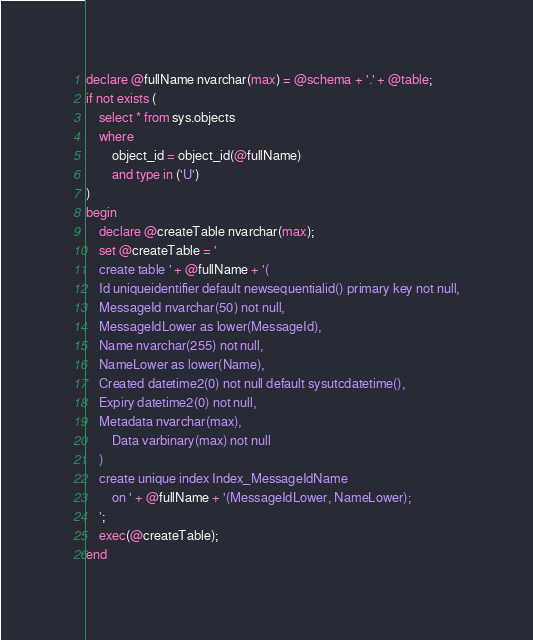<code> <loc_0><loc_0><loc_500><loc_500><_SQL_>declare @fullName nvarchar(max) = @schema + '.' + @table;
if not exists (
    select * from sys.objects
    where
        object_id = object_id(@fullName)
        and type in ('U')
)
begin
    declare @createTable nvarchar(max);
    set @createTable = '
    create table ' + @fullName + '(
    Id uniqueidentifier default newsequentialid() primary key not null,
    MessageId nvarchar(50) not null,
    MessageIdLower as lower(MessageId),
    Name nvarchar(255) not null,
    NameLower as lower(Name),
    Created datetime2(0) not null default sysutcdatetime(),
    Expiry datetime2(0) not null,
    Metadata nvarchar(max),
        Data varbinary(max) not null
    )
    create unique index Index_MessageIdName
        on ' + @fullName + '(MessageIdLower, NameLower);
    ';
    exec(@createTable);
end</code> 